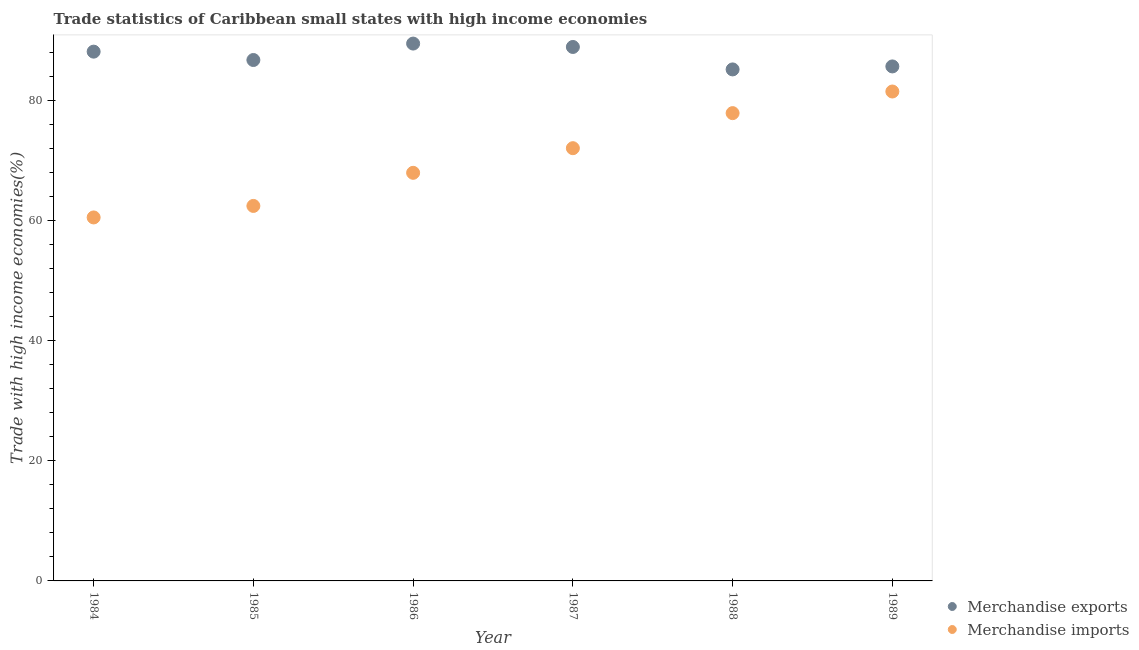How many different coloured dotlines are there?
Give a very brief answer. 2. What is the merchandise imports in 1985?
Provide a succinct answer. 62.44. Across all years, what is the maximum merchandise imports?
Provide a succinct answer. 81.5. Across all years, what is the minimum merchandise exports?
Your response must be concise. 85.17. In which year was the merchandise imports maximum?
Ensure brevity in your answer.  1989. What is the total merchandise imports in the graph?
Give a very brief answer. 422.37. What is the difference between the merchandise exports in 1987 and that in 1989?
Make the answer very short. 3.24. What is the difference between the merchandise imports in 1985 and the merchandise exports in 1986?
Ensure brevity in your answer.  -27.04. What is the average merchandise exports per year?
Keep it short and to the point. 87.35. In the year 1986, what is the difference between the merchandise exports and merchandise imports?
Offer a very short reply. 21.52. What is the ratio of the merchandise exports in 1985 to that in 1988?
Your response must be concise. 1.02. Is the difference between the merchandise exports in 1985 and 1989 greater than the difference between the merchandise imports in 1985 and 1989?
Provide a succinct answer. Yes. What is the difference between the highest and the second highest merchandise imports?
Ensure brevity in your answer.  3.6. What is the difference between the highest and the lowest merchandise exports?
Provide a succinct answer. 4.3. In how many years, is the merchandise exports greater than the average merchandise exports taken over all years?
Your response must be concise. 3. Does the merchandise exports monotonically increase over the years?
Your response must be concise. No. Is the merchandise exports strictly greater than the merchandise imports over the years?
Offer a terse response. Yes. How many dotlines are there?
Your answer should be very brief. 2. What is the difference between two consecutive major ticks on the Y-axis?
Keep it short and to the point. 20. Does the graph contain any zero values?
Your response must be concise. No. Does the graph contain grids?
Your response must be concise. No. Where does the legend appear in the graph?
Your answer should be very brief. Bottom right. How many legend labels are there?
Your answer should be compact. 2. What is the title of the graph?
Make the answer very short. Trade statistics of Caribbean small states with high income economies. Does "Female population" appear as one of the legend labels in the graph?
Ensure brevity in your answer.  No. What is the label or title of the X-axis?
Ensure brevity in your answer.  Year. What is the label or title of the Y-axis?
Provide a succinct answer. Trade with high income economies(%). What is the Trade with high income economies(%) in Merchandise exports in 1984?
Give a very brief answer. 88.13. What is the Trade with high income economies(%) of Merchandise imports in 1984?
Provide a short and direct response. 60.53. What is the Trade with high income economies(%) in Merchandise exports in 1985?
Your answer should be compact. 86.74. What is the Trade with high income economies(%) in Merchandise imports in 1985?
Provide a short and direct response. 62.44. What is the Trade with high income economies(%) in Merchandise exports in 1986?
Ensure brevity in your answer.  89.48. What is the Trade with high income economies(%) of Merchandise imports in 1986?
Give a very brief answer. 67.96. What is the Trade with high income economies(%) of Merchandise exports in 1987?
Ensure brevity in your answer.  88.91. What is the Trade with high income economies(%) of Merchandise imports in 1987?
Make the answer very short. 72.06. What is the Trade with high income economies(%) of Merchandise exports in 1988?
Keep it short and to the point. 85.17. What is the Trade with high income economies(%) in Merchandise imports in 1988?
Give a very brief answer. 77.89. What is the Trade with high income economies(%) of Merchandise exports in 1989?
Offer a very short reply. 85.67. What is the Trade with high income economies(%) of Merchandise imports in 1989?
Offer a very short reply. 81.5. Across all years, what is the maximum Trade with high income economies(%) in Merchandise exports?
Keep it short and to the point. 89.48. Across all years, what is the maximum Trade with high income economies(%) of Merchandise imports?
Your response must be concise. 81.5. Across all years, what is the minimum Trade with high income economies(%) of Merchandise exports?
Provide a succinct answer. 85.17. Across all years, what is the minimum Trade with high income economies(%) in Merchandise imports?
Keep it short and to the point. 60.53. What is the total Trade with high income economies(%) of Merchandise exports in the graph?
Provide a short and direct response. 524.11. What is the total Trade with high income economies(%) of Merchandise imports in the graph?
Offer a very short reply. 422.37. What is the difference between the Trade with high income economies(%) in Merchandise exports in 1984 and that in 1985?
Provide a short and direct response. 1.39. What is the difference between the Trade with high income economies(%) in Merchandise imports in 1984 and that in 1985?
Give a very brief answer. -1.92. What is the difference between the Trade with high income economies(%) in Merchandise exports in 1984 and that in 1986?
Offer a very short reply. -1.34. What is the difference between the Trade with high income economies(%) in Merchandise imports in 1984 and that in 1986?
Make the answer very short. -7.43. What is the difference between the Trade with high income economies(%) in Merchandise exports in 1984 and that in 1987?
Ensure brevity in your answer.  -0.78. What is the difference between the Trade with high income economies(%) in Merchandise imports in 1984 and that in 1987?
Provide a succinct answer. -11.53. What is the difference between the Trade with high income economies(%) of Merchandise exports in 1984 and that in 1988?
Make the answer very short. 2.96. What is the difference between the Trade with high income economies(%) in Merchandise imports in 1984 and that in 1988?
Your response must be concise. -17.37. What is the difference between the Trade with high income economies(%) in Merchandise exports in 1984 and that in 1989?
Provide a short and direct response. 2.46. What is the difference between the Trade with high income economies(%) in Merchandise imports in 1984 and that in 1989?
Keep it short and to the point. -20.97. What is the difference between the Trade with high income economies(%) of Merchandise exports in 1985 and that in 1986?
Give a very brief answer. -2.74. What is the difference between the Trade with high income economies(%) of Merchandise imports in 1985 and that in 1986?
Provide a short and direct response. -5.51. What is the difference between the Trade with high income economies(%) of Merchandise exports in 1985 and that in 1987?
Your answer should be very brief. -2.17. What is the difference between the Trade with high income economies(%) of Merchandise imports in 1985 and that in 1987?
Keep it short and to the point. -9.61. What is the difference between the Trade with high income economies(%) in Merchandise exports in 1985 and that in 1988?
Your answer should be very brief. 1.57. What is the difference between the Trade with high income economies(%) in Merchandise imports in 1985 and that in 1988?
Your response must be concise. -15.45. What is the difference between the Trade with high income economies(%) of Merchandise exports in 1985 and that in 1989?
Give a very brief answer. 1.07. What is the difference between the Trade with high income economies(%) of Merchandise imports in 1985 and that in 1989?
Provide a succinct answer. -19.05. What is the difference between the Trade with high income economies(%) in Merchandise exports in 1986 and that in 1987?
Offer a very short reply. 0.57. What is the difference between the Trade with high income economies(%) of Merchandise imports in 1986 and that in 1987?
Offer a terse response. -4.1. What is the difference between the Trade with high income economies(%) in Merchandise exports in 1986 and that in 1988?
Provide a succinct answer. 4.3. What is the difference between the Trade with high income economies(%) in Merchandise imports in 1986 and that in 1988?
Ensure brevity in your answer.  -9.94. What is the difference between the Trade with high income economies(%) in Merchandise exports in 1986 and that in 1989?
Provide a succinct answer. 3.81. What is the difference between the Trade with high income economies(%) in Merchandise imports in 1986 and that in 1989?
Provide a succinct answer. -13.54. What is the difference between the Trade with high income economies(%) of Merchandise exports in 1987 and that in 1988?
Ensure brevity in your answer.  3.74. What is the difference between the Trade with high income economies(%) of Merchandise imports in 1987 and that in 1988?
Provide a succinct answer. -5.84. What is the difference between the Trade with high income economies(%) in Merchandise exports in 1987 and that in 1989?
Offer a terse response. 3.24. What is the difference between the Trade with high income economies(%) of Merchandise imports in 1987 and that in 1989?
Offer a very short reply. -9.44. What is the difference between the Trade with high income economies(%) in Merchandise exports in 1988 and that in 1989?
Give a very brief answer. -0.5. What is the difference between the Trade with high income economies(%) of Merchandise imports in 1988 and that in 1989?
Offer a terse response. -3.6. What is the difference between the Trade with high income economies(%) of Merchandise exports in 1984 and the Trade with high income economies(%) of Merchandise imports in 1985?
Offer a very short reply. 25.69. What is the difference between the Trade with high income economies(%) in Merchandise exports in 1984 and the Trade with high income economies(%) in Merchandise imports in 1986?
Offer a terse response. 20.18. What is the difference between the Trade with high income economies(%) of Merchandise exports in 1984 and the Trade with high income economies(%) of Merchandise imports in 1987?
Offer a very short reply. 16.08. What is the difference between the Trade with high income economies(%) in Merchandise exports in 1984 and the Trade with high income economies(%) in Merchandise imports in 1988?
Provide a succinct answer. 10.24. What is the difference between the Trade with high income economies(%) in Merchandise exports in 1984 and the Trade with high income economies(%) in Merchandise imports in 1989?
Your answer should be very brief. 6.64. What is the difference between the Trade with high income economies(%) in Merchandise exports in 1985 and the Trade with high income economies(%) in Merchandise imports in 1986?
Offer a terse response. 18.78. What is the difference between the Trade with high income economies(%) of Merchandise exports in 1985 and the Trade with high income economies(%) of Merchandise imports in 1987?
Provide a succinct answer. 14.68. What is the difference between the Trade with high income economies(%) of Merchandise exports in 1985 and the Trade with high income economies(%) of Merchandise imports in 1988?
Provide a succinct answer. 8.84. What is the difference between the Trade with high income economies(%) in Merchandise exports in 1985 and the Trade with high income economies(%) in Merchandise imports in 1989?
Offer a terse response. 5.24. What is the difference between the Trade with high income economies(%) in Merchandise exports in 1986 and the Trade with high income economies(%) in Merchandise imports in 1987?
Give a very brief answer. 17.42. What is the difference between the Trade with high income economies(%) of Merchandise exports in 1986 and the Trade with high income economies(%) of Merchandise imports in 1988?
Offer a terse response. 11.58. What is the difference between the Trade with high income economies(%) of Merchandise exports in 1986 and the Trade with high income economies(%) of Merchandise imports in 1989?
Ensure brevity in your answer.  7.98. What is the difference between the Trade with high income economies(%) in Merchandise exports in 1987 and the Trade with high income economies(%) in Merchandise imports in 1988?
Your answer should be compact. 11.02. What is the difference between the Trade with high income economies(%) of Merchandise exports in 1987 and the Trade with high income economies(%) of Merchandise imports in 1989?
Keep it short and to the point. 7.42. What is the difference between the Trade with high income economies(%) in Merchandise exports in 1988 and the Trade with high income economies(%) in Merchandise imports in 1989?
Provide a short and direct response. 3.68. What is the average Trade with high income economies(%) of Merchandise exports per year?
Make the answer very short. 87.35. What is the average Trade with high income economies(%) of Merchandise imports per year?
Offer a terse response. 70.4. In the year 1984, what is the difference between the Trade with high income economies(%) of Merchandise exports and Trade with high income economies(%) of Merchandise imports?
Provide a short and direct response. 27.61. In the year 1985, what is the difference between the Trade with high income economies(%) of Merchandise exports and Trade with high income economies(%) of Merchandise imports?
Keep it short and to the point. 24.3. In the year 1986, what is the difference between the Trade with high income economies(%) of Merchandise exports and Trade with high income economies(%) of Merchandise imports?
Offer a terse response. 21.52. In the year 1987, what is the difference between the Trade with high income economies(%) of Merchandise exports and Trade with high income economies(%) of Merchandise imports?
Provide a short and direct response. 16.85. In the year 1988, what is the difference between the Trade with high income economies(%) in Merchandise exports and Trade with high income economies(%) in Merchandise imports?
Make the answer very short. 7.28. In the year 1989, what is the difference between the Trade with high income economies(%) in Merchandise exports and Trade with high income economies(%) in Merchandise imports?
Offer a terse response. 4.18. What is the ratio of the Trade with high income economies(%) of Merchandise exports in 1984 to that in 1985?
Your answer should be very brief. 1.02. What is the ratio of the Trade with high income economies(%) in Merchandise imports in 1984 to that in 1985?
Make the answer very short. 0.97. What is the ratio of the Trade with high income economies(%) in Merchandise exports in 1984 to that in 1986?
Ensure brevity in your answer.  0.98. What is the ratio of the Trade with high income economies(%) in Merchandise imports in 1984 to that in 1986?
Offer a terse response. 0.89. What is the ratio of the Trade with high income economies(%) of Merchandise imports in 1984 to that in 1987?
Keep it short and to the point. 0.84. What is the ratio of the Trade with high income economies(%) in Merchandise exports in 1984 to that in 1988?
Your answer should be compact. 1.03. What is the ratio of the Trade with high income economies(%) in Merchandise imports in 1984 to that in 1988?
Offer a terse response. 0.78. What is the ratio of the Trade with high income economies(%) of Merchandise exports in 1984 to that in 1989?
Keep it short and to the point. 1.03. What is the ratio of the Trade with high income economies(%) of Merchandise imports in 1984 to that in 1989?
Make the answer very short. 0.74. What is the ratio of the Trade with high income economies(%) of Merchandise exports in 1985 to that in 1986?
Your answer should be very brief. 0.97. What is the ratio of the Trade with high income economies(%) in Merchandise imports in 1985 to that in 1986?
Offer a terse response. 0.92. What is the ratio of the Trade with high income economies(%) in Merchandise exports in 1985 to that in 1987?
Offer a terse response. 0.98. What is the ratio of the Trade with high income economies(%) of Merchandise imports in 1985 to that in 1987?
Offer a terse response. 0.87. What is the ratio of the Trade with high income economies(%) of Merchandise exports in 1985 to that in 1988?
Provide a succinct answer. 1.02. What is the ratio of the Trade with high income economies(%) in Merchandise imports in 1985 to that in 1988?
Offer a very short reply. 0.8. What is the ratio of the Trade with high income economies(%) of Merchandise exports in 1985 to that in 1989?
Make the answer very short. 1.01. What is the ratio of the Trade with high income economies(%) of Merchandise imports in 1985 to that in 1989?
Provide a short and direct response. 0.77. What is the ratio of the Trade with high income economies(%) in Merchandise exports in 1986 to that in 1987?
Give a very brief answer. 1.01. What is the ratio of the Trade with high income economies(%) in Merchandise imports in 1986 to that in 1987?
Keep it short and to the point. 0.94. What is the ratio of the Trade with high income economies(%) in Merchandise exports in 1986 to that in 1988?
Keep it short and to the point. 1.05. What is the ratio of the Trade with high income economies(%) in Merchandise imports in 1986 to that in 1988?
Your answer should be very brief. 0.87. What is the ratio of the Trade with high income economies(%) of Merchandise exports in 1986 to that in 1989?
Provide a short and direct response. 1.04. What is the ratio of the Trade with high income economies(%) in Merchandise imports in 1986 to that in 1989?
Offer a very short reply. 0.83. What is the ratio of the Trade with high income economies(%) of Merchandise exports in 1987 to that in 1988?
Your answer should be very brief. 1.04. What is the ratio of the Trade with high income economies(%) in Merchandise imports in 1987 to that in 1988?
Your answer should be compact. 0.93. What is the ratio of the Trade with high income economies(%) in Merchandise exports in 1987 to that in 1989?
Make the answer very short. 1.04. What is the ratio of the Trade with high income economies(%) in Merchandise imports in 1987 to that in 1989?
Provide a succinct answer. 0.88. What is the ratio of the Trade with high income economies(%) in Merchandise imports in 1988 to that in 1989?
Offer a terse response. 0.96. What is the difference between the highest and the second highest Trade with high income economies(%) of Merchandise exports?
Offer a very short reply. 0.57. What is the difference between the highest and the second highest Trade with high income economies(%) in Merchandise imports?
Offer a very short reply. 3.6. What is the difference between the highest and the lowest Trade with high income economies(%) of Merchandise exports?
Your response must be concise. 4.3. What is the difference between the highest and the lowest Trade with high income economies(%) of Merchandise imports?
Give a very brief answer. 20.97. 